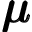<formula> <loc_0><loc_0><loc_500><loc_500>\pm b { \mu }</formula> 